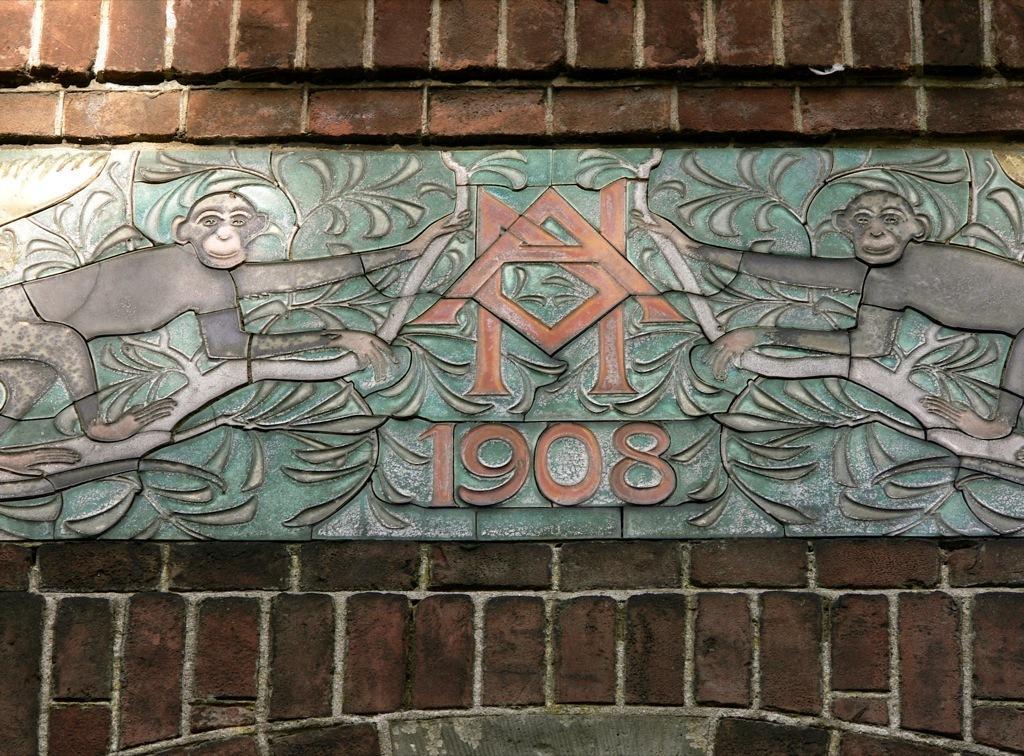Describe this image in one or two sentences. In this image we can see a carving on the wall. In the background of the image there is a wall. 